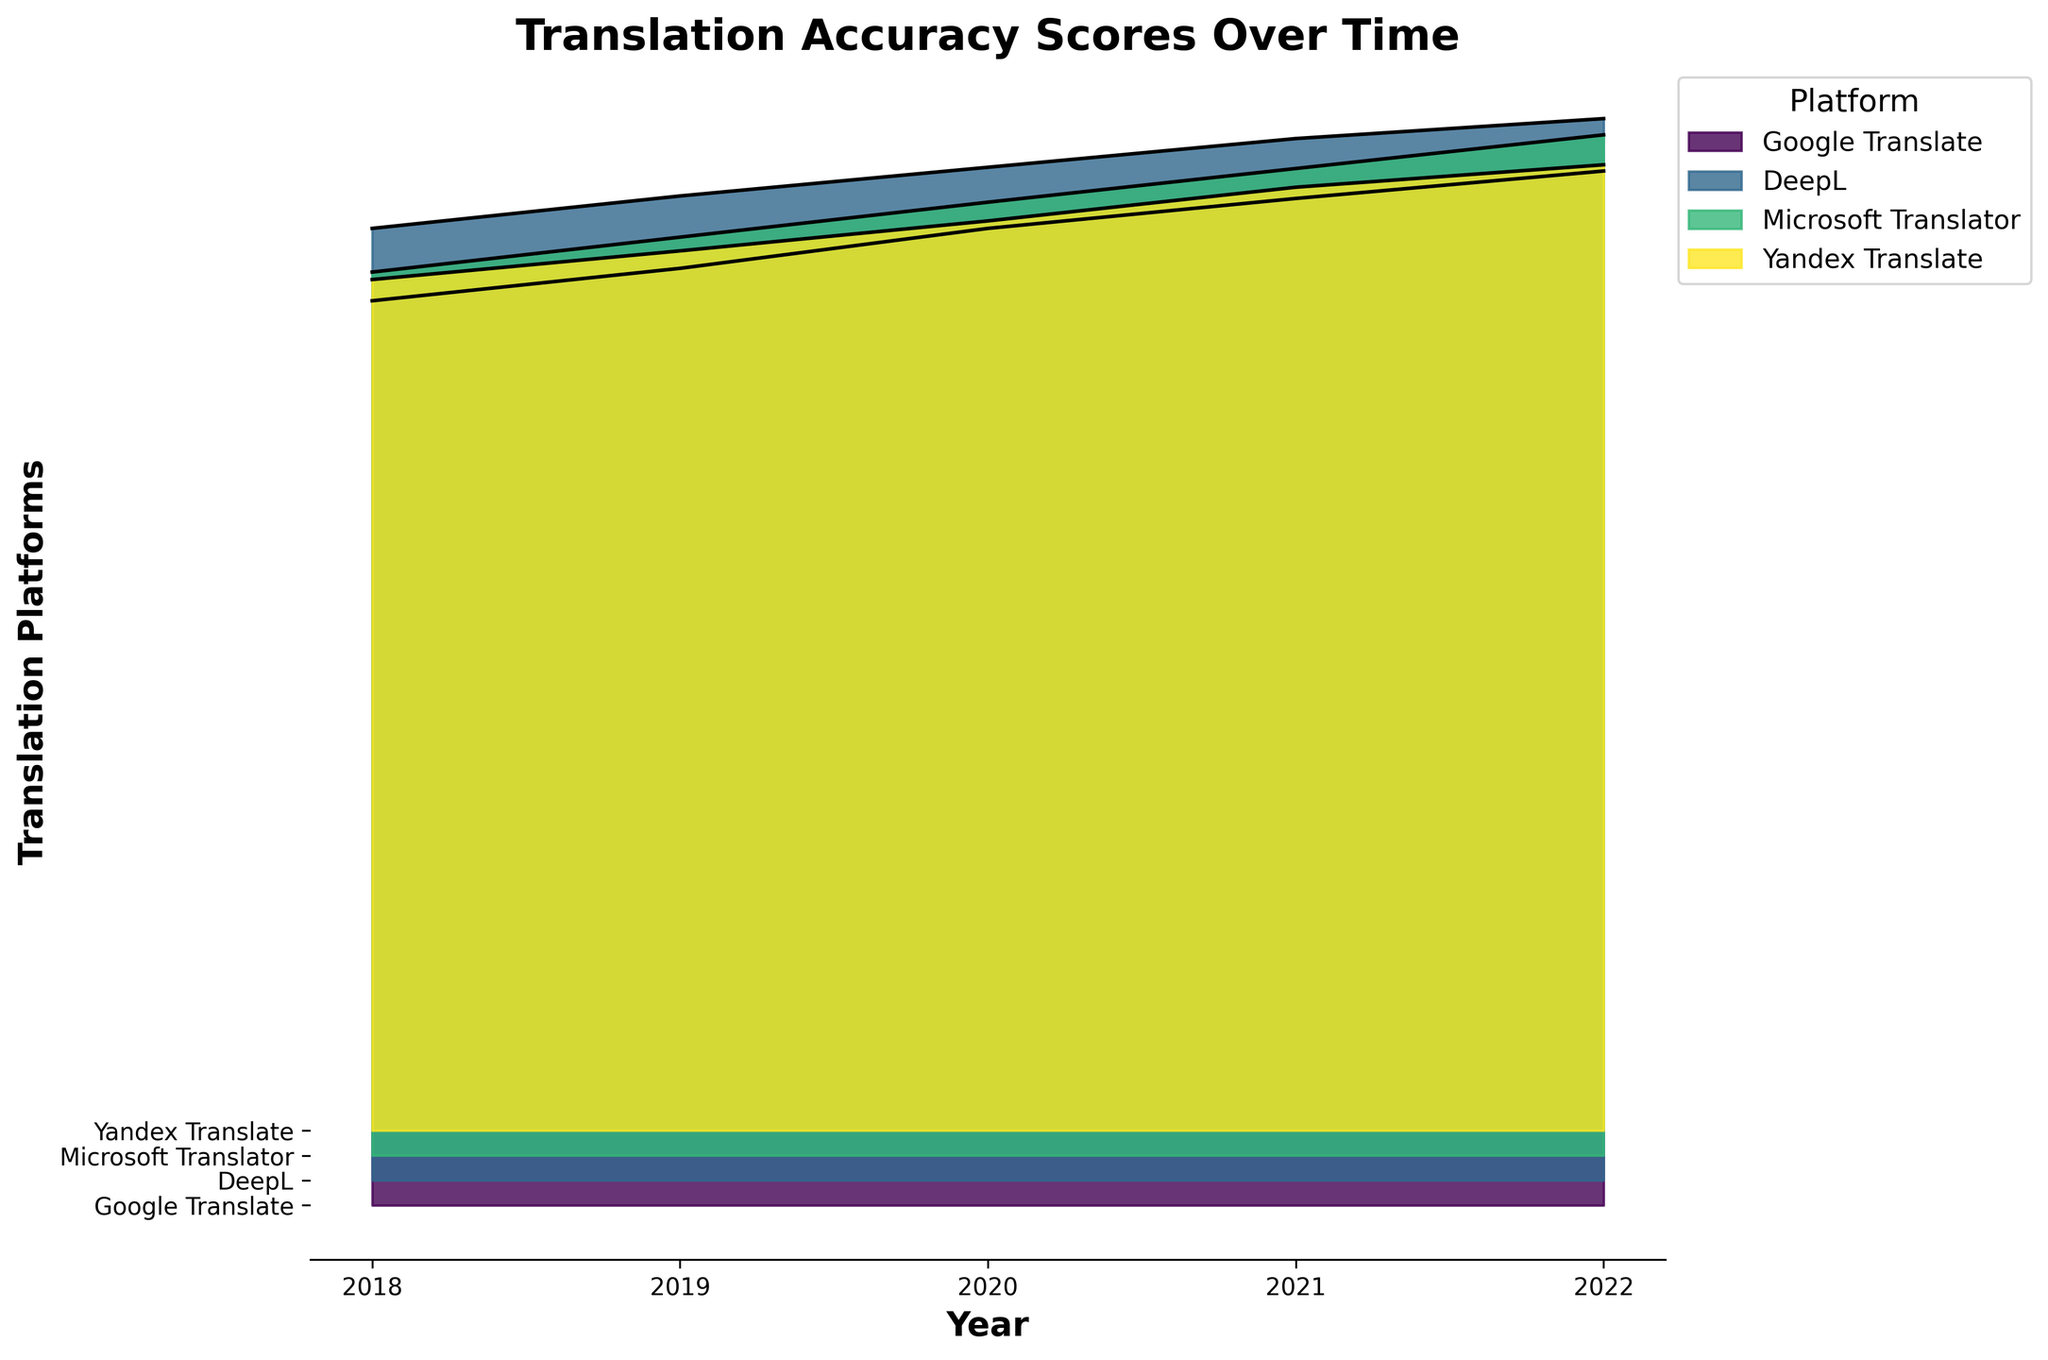Which platform has the highest translation accuracy score in 2022? By looking at the highest points of the filled areas in 2022, we can see that DeepL has the highest score.
Answer: DeepL How does Google Translate's accuracy score change from 2018 to 2022? Observing the Google Translate scores over the years, it starts from 72.5 in 2018 and increases to 82.9 in 2022.
Answer: Increase Which platform showed the most consistent improvement over the years? By examining the trend lines of the filled areas for each platform, DeepL consistently shows an upward trend without any decline.
Answer: DeepL What is the score difference between DeepL and Microsoft Translator in 2022? DeepL in 2022 is 85.1, and Microsoft Translator is 81.8. Calculating the difference, 85.1 - 81.8 gives 3.3.
Answer: 3.3 In which year did Yandex Translate have its highest accuracy score? Checking the peak points of the filled areas specific to Yandex Translate across the years, its highest point is in 2022.
Answer: 2022 How do the scores of all platforms compare in 2020? Comparing the heights of the filled areas in 2020, DeepL is the highest, followed by Google Translate, Microsoft Translator, and Yandex Translate.
Answer: DeepL > Google Translate > Microsoft Translator > Yandex Translate Which platform had a lower score than Google Translate in 2018? Observing 2018 scores, Microsoft Translator and Yandex Translate both have lower scores than Google Translate.
Answer: Microsoft Translator, Yandex Translate What is the average score of Google Translate over the years? Adding Google Translate's scores for each year (72.5 + 75.1 + 78.3 + 80.7 + 82.9) and dividing by the number of years (5), we get (72.5 + 75.1 + 78.3 + 80.7 + 82.9) / 5 = 77.9.
Answer: 77.9 How does the growth rate of Microsoft Translator compare to DeepL from 2018 to 2022? Microsoft Translator starts at 70.8 in 2018 and reaches 81.8 in 2022, an increase of 11 points. DeepL starts at 76.3 in 2018 and reaches 85.1 in 2022, an increase of 8.8 points. Hence, Microsoft Translator has a higher point increase.
Answer: Microsoft Translator higher Which platform saw the least improvement in translation accuracy from 2018 to 2022? By checking the filled areas, Yandex Translate had the smallest change in accuracy scores from 68.2 in 2018 to 77.4 in 2022, a 9.2-point increase.
Answer: Yandex Translate 